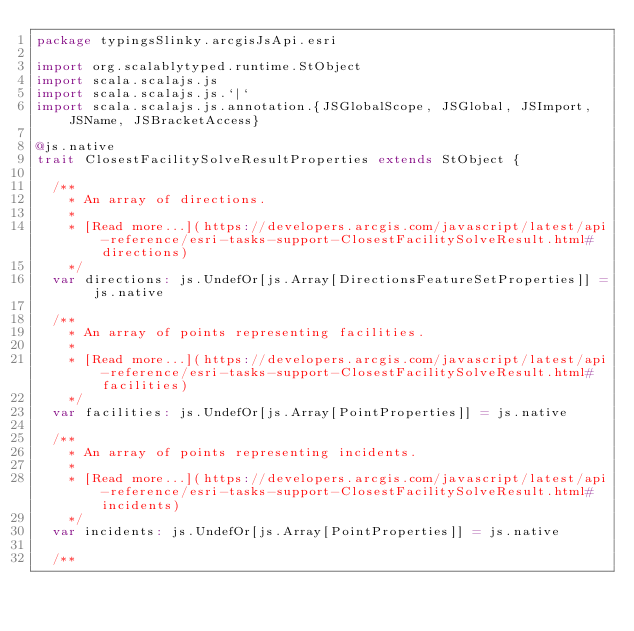<code> <loc_0><loc_0><loc_500><loc_500><_Scala_>package typingsSlinky.arcgisJsApi.esri

import org.scalablytyped.runtime.StObject
import scala.scalajs.js
import scala.scalajs.js.`|`
import scala.scalajs.js.annotation.{JSGlobalScope, JSGlobal, JSImport, JSName, JSBracketAccess}

@js.native
trait ClosestFacilitySolveResultProperties extends StObject {
  
  /**
    * An array of directions.
    *
    * [Read more...](https://developers.arcgis.com/javascript/latest/api-reference/esri-tasks-support-ClosestFacilitySolveResult.html#directions)
    */
  var directions: js.UndefOr[js.Array[DirectionsFeatureSetProperties]] = js.native
  
  /**
    * An array of points representing facilities.
    *
    * [Read more...](https://developers.arcgis.com/javascript/latest/api-reference/esri-tasks-support-ClosestFacilitySolveResult.html#facilities)
    */
  var facilities: js.UndefOr[js.Array[PointProperties]] = js.native
  
  /**
    * An array of points representing incidents.
    *
    * [Read more...](https://developers.arcgis.com/javascript/latest/api-reference/esri-tasks-support-ClosestFacilitySolveResult.html#incidents)
    */
  var incidents: js.UndefOr[js.Array[PointProperties]] = js.native
  
  /**</code> 